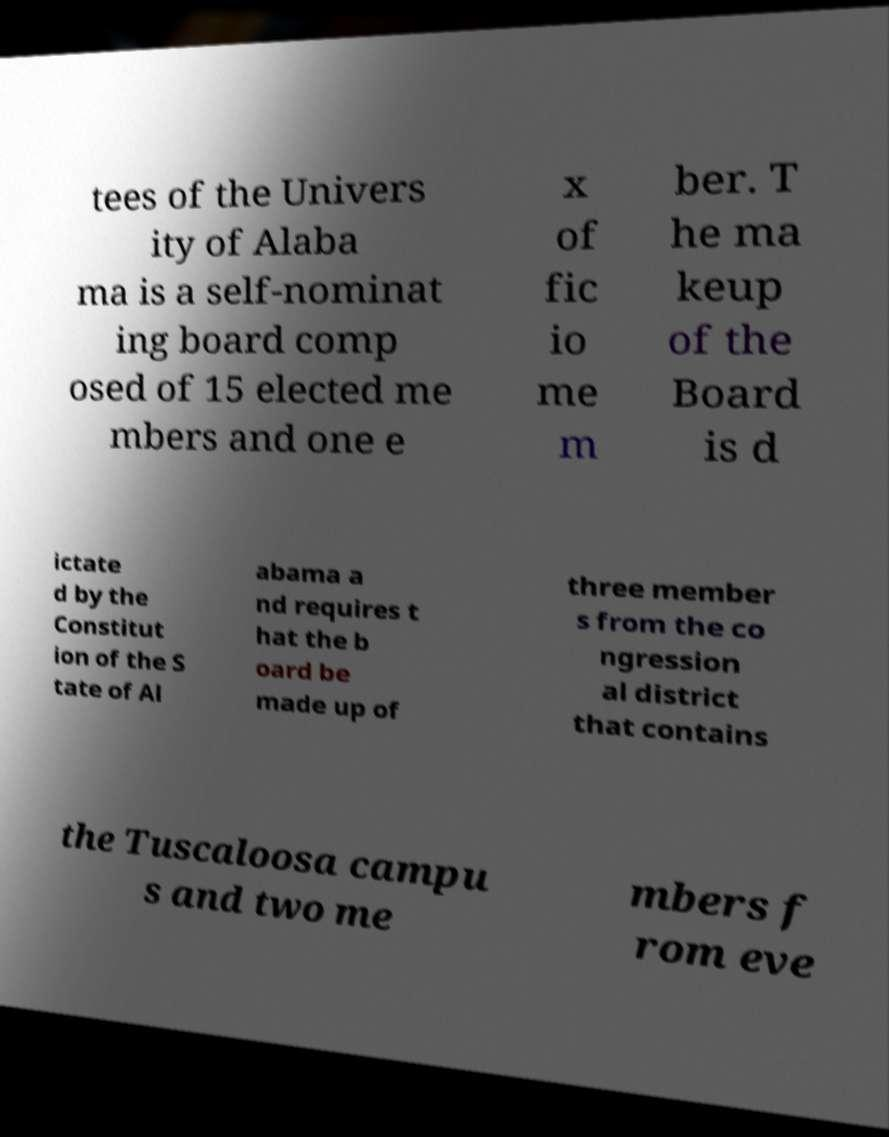Can you read and provide the text displayed in the image?This photo seems to have some interesting text. Can you extract and type it out for me? tees of the Univers ity of Alaba ma is a self-nominat ing board comp osed of 15 elected me mbers and one e x of fic io me m ber. T he ma keup of the Board is d ictate d by the Constitut ion of the S tate of Al abama a nd requires t hat the b oard be made up of three member s from the co ngression al district that contains the Tuscaloosa campu s and two me mbers f rom eve 